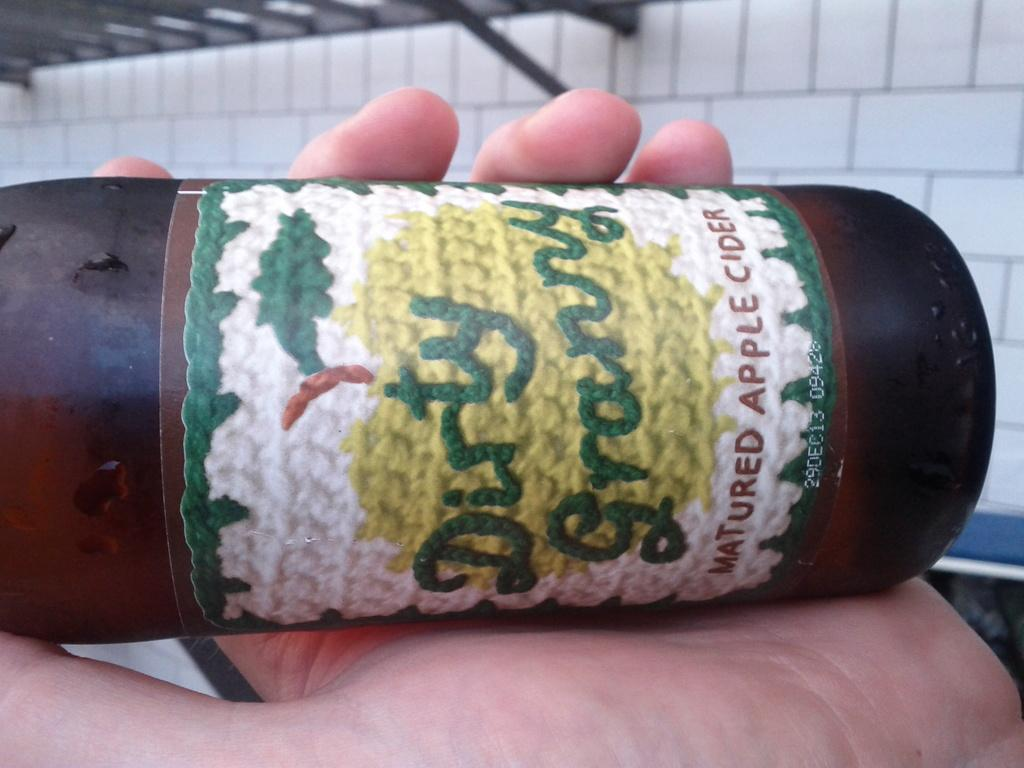<image>
Relay a brief, clear account of the picture shown. A hand is holding on its side a bottle of Dirty granny apple cider. 